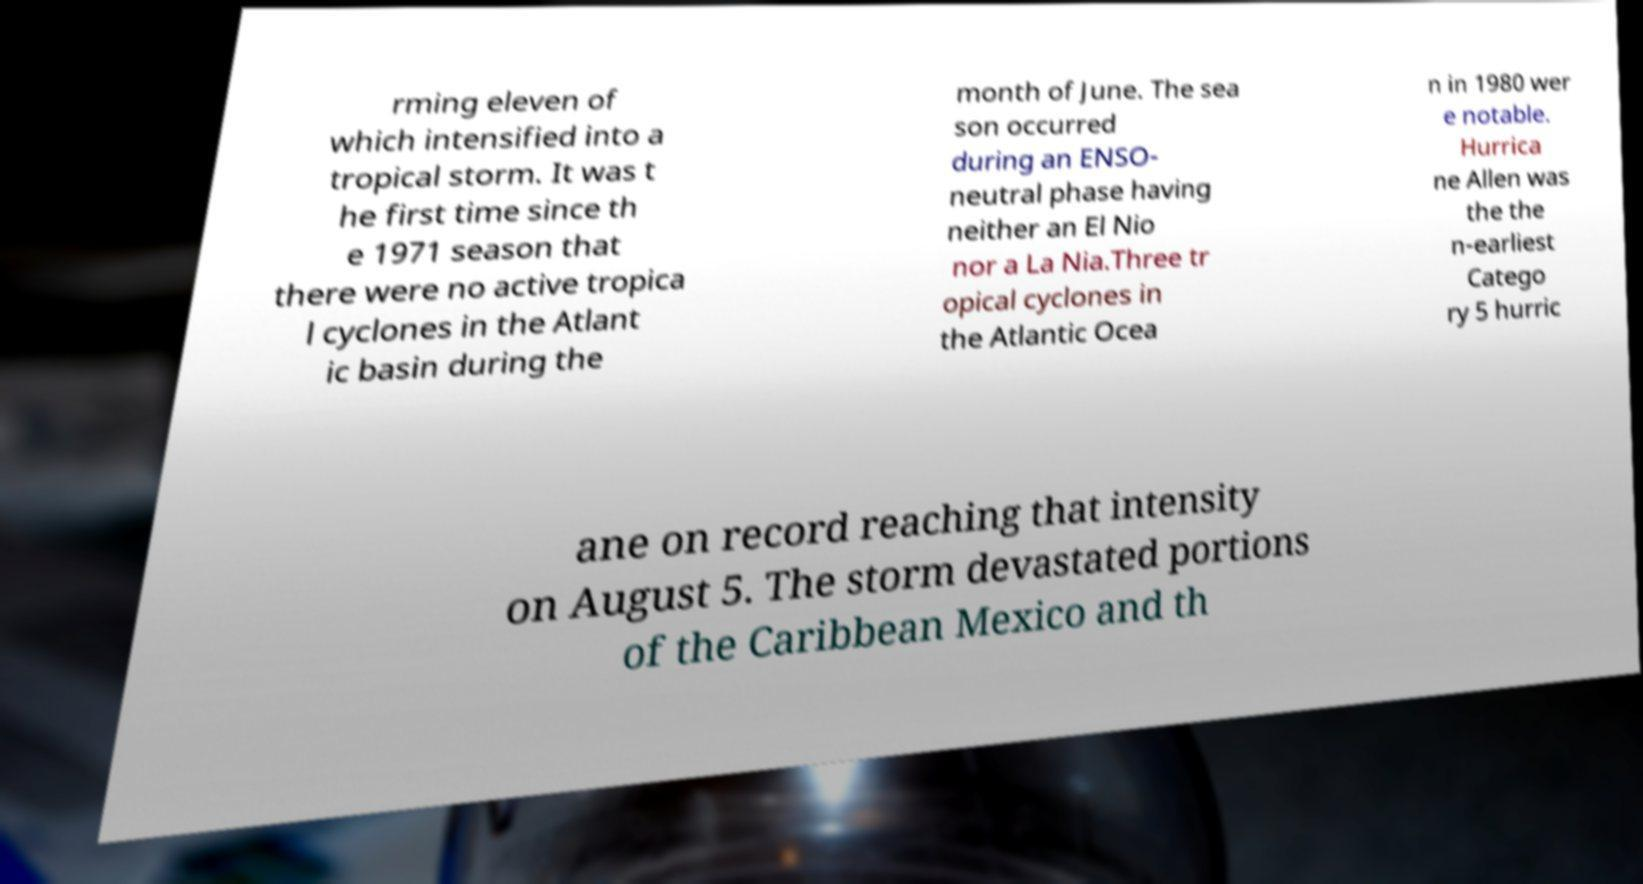Can you accurately transcribe the text from the provided image for me? rming eleven of which intensified into a tropical storm. It was t he first time since th e 1971 season that there were no active tropica l cyclones in the Atlant ic basin during the month of June. The sea son occurred during an ENSO- neutral phase having neither an El Nio nor a La Nia.Three tr opical cyclones in the Atlantic Ocea n in 1980 wer e notable. Hurrica ne Allen was the the n-earliest Catego ry 5 hurric ane on record reaching that intensity on August 5. The storm devastated portions of the Caribbean Mexico and th 